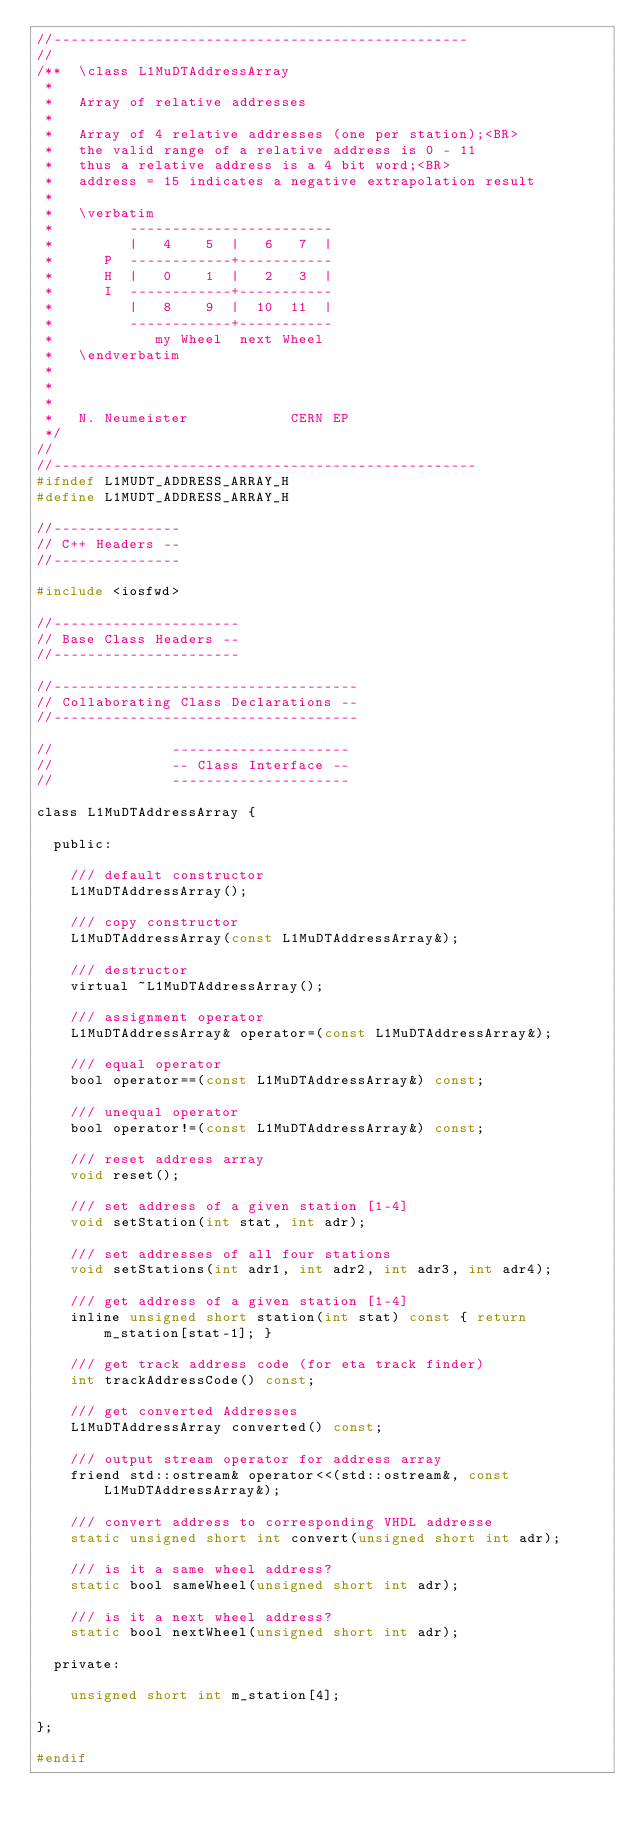<code> <loc_0><loc_0><loc_500><loc_500><_C_>//-------------------------------------------------
//
/**  \class L1MuDTAddressArray
 *
 *   Array of relative addresses
 *
 *   Array of 4 relative addresses (one per station);<BR>
 *   the valid range of a relative address is 0 - 11
 *   thus a relative address is a 4 bit word;<BR>
 *   address = 15 indicates a negative extrapolation result
 *
 *   \verbatim
 *         ------------------------
 *         |   4    5  |   6   7  |
 *      P  ------------+-----------
 *      H  |   0    1  |   2   3  |
 *      I  ------------+-----------
 *         |   8    9  |  10  11  |
 *         ------------+-----------
 *            my Wheel  next Wheel
 *   \endverbatim
 *
 *
 *
 *   N. Neumeister            CERN EP
 */
//
//--------------------------------------------------
#ifndef L1MUDT_ADDRESS_ARRAY_H
#define L1MUDT_ADDRESS_ARRAY_H

//---------------
// C++ Headers --
//---------------

#include <iosfwd>

//----------------------
// Base Class Headers --
//----------------------

//------------------------------------
// Collaborating Class Declarations --
//------------------------------------

//              ---------------------
//              -- Class Interface --
//              ---------------------

class L1MuDTAddressArray {

  public:

    /// default constructor
    L1MuDTAddressArray();

    /// copy constructor
    L1MuDTAddressArray(const L1MuDTAddressArray&);

    /// destructor
    virtual ~L1MuDTAddressArray();

    /// assignment operator
    L1MuDTAddressArray& operator=(const L1MuDTAddressArray&);

    /// equal operator
    bool operator==(const L1MuDTAddressArray&) const;
   
    /// unequal operator
    bool operator!=(const L1MuDTAddressArray&) const;

    /// reset address array
    void reset();

    /// set address of a given station [1-4]
    void setStation(int stat, int adr);
    
    /// set addresses of all four stations
    void setStations(int adr1, int adr2, int adr3, int adr4);

    /// get address of a given station [1-4]
    inline unsigned short station(int stat) const { return m_station[stat-1]; } 

    /// get track address code (for eta track finder)
    int trackAddressCode() const;

    /// get converted Addresses
    L1MuDTAddressArray converted() const;

    /// output stream operator for address array
    friend std::ostream& operator<<(std::ostream&, const L1MuDTAddressArray&);

    /// convert address to corresponding VHDL addresse
    static unsigned short int convert(unsigned short int adr);
    
    /// is it a same wheel address?
    static bool sameWheel(unsigned short int adr);
    
    /// is it a next wheel address?
    static bool nextWheel(unsigned short int adr);

  private:
  
    unsigned short int m_station[4];

};

#endif
</code> 